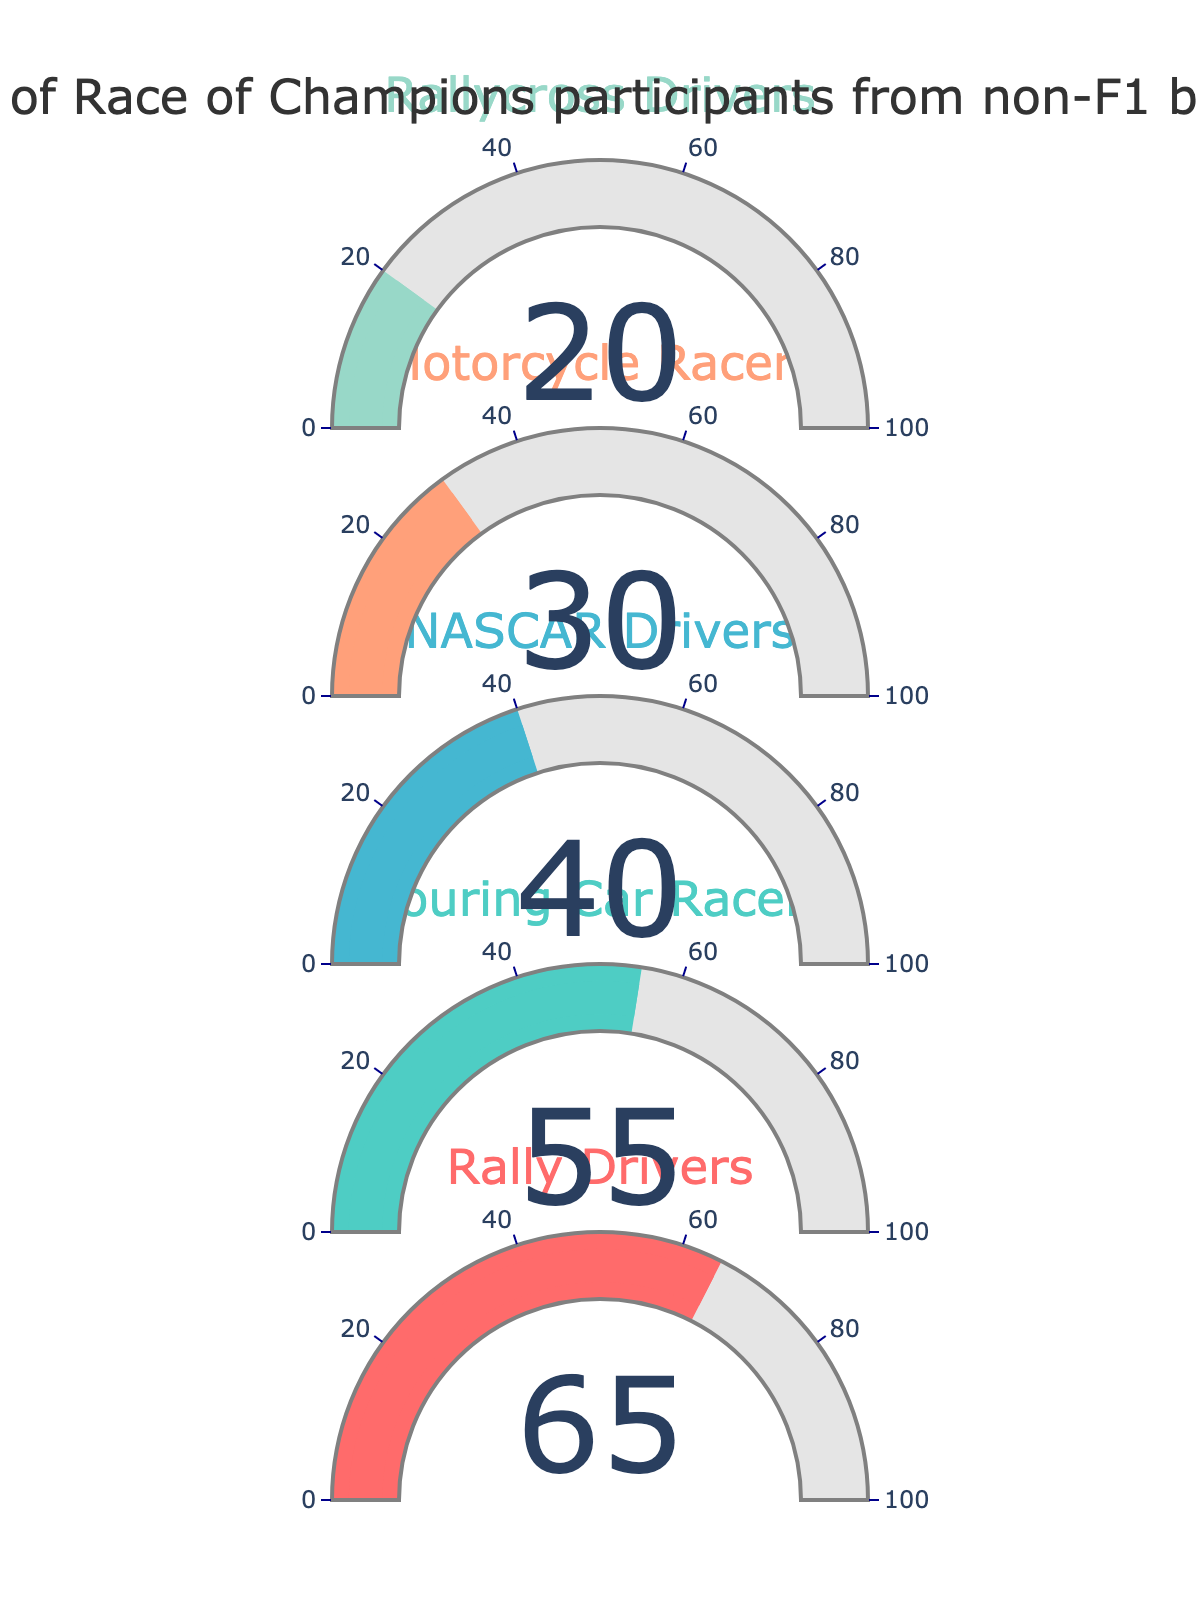What's the percentage of Race of Champions participants from Rally backgrounds? The gauge chart displays the percentages for each category, and the Rally Drivers section shows 65%.
Answer: 65% Which category has the lowest percentage of Race of Champions participants? To determine the lowest value, look through each of the categories and identify the smallest percentage. The Rallycross Drivers have the lowest value at 20%.
Answer: Rallycross Drivers How many categories have more than 50% participation from non-F1 backgrounds? Check each category's percentage. Rally Drivers (65%) and Touring Car Racers (55%) have percentages greater than 50%.
Answer: 2 What is the difference in percentage between Rally Drivers and Motorcycle Racers? Subtract the percentage of Motorcycle Racers (30%) from the percentage of Rally Drivers (65%): 65% - 30% = 35%.
Answer: 35% What are the total participants from Rallycross and Touring Car backgrounds combined? Add the percentages of Rallycross Drivers (20%) and Touring Car Racers (55%): 20% + 55% = 75%.
Answer: 75% Which two categories have the closest percentages? Compare each pair of categories to find the smallest difference. The closest percentages are 55% (Touring Car Racers) and 40% (NASCAR Drivers), with a difference of 15%.
Answer: Touring Car Racers and NASCAR Drivers What's the average percentage of participants from non-F1 backgrounds across all categories? Sum the percentages for all categories: 65% + 55% + 40% + 30% + 20% = 210%. Divide by the number of categories: 210% / 5 = 42%.
Answer: 42% Does any category have exactly 50% participation? Examine each category’s gauge and identify any that exactly hit the 50% mark. No category displays exactly 50% participation.
Answer: No Are there more participants from NASCAR or Motorcycle backgrounds? Compare the percentage values for NASCAR Drivers (40%) and Motorcycle Racers (30%). NASCAR Drivers have more participants.
Answer: NASCAR Drivers 